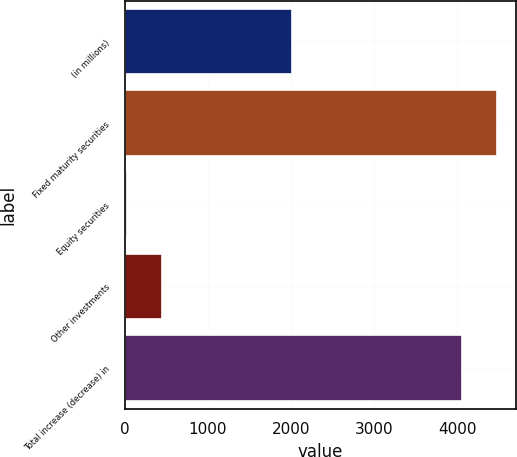<chart> <loc_0><loc_0><loc_500><loc_500><bar_chart><fcel>(in millions)<fcel>Fixed maturity securities<fcel>Equity securities<fcel>Other investments<fcel>Total increase (decrease) in<nl><fcel>2017<fcel>4483.3<fcel>22<fcel>443.3<fcel>4062<nl></chart> 